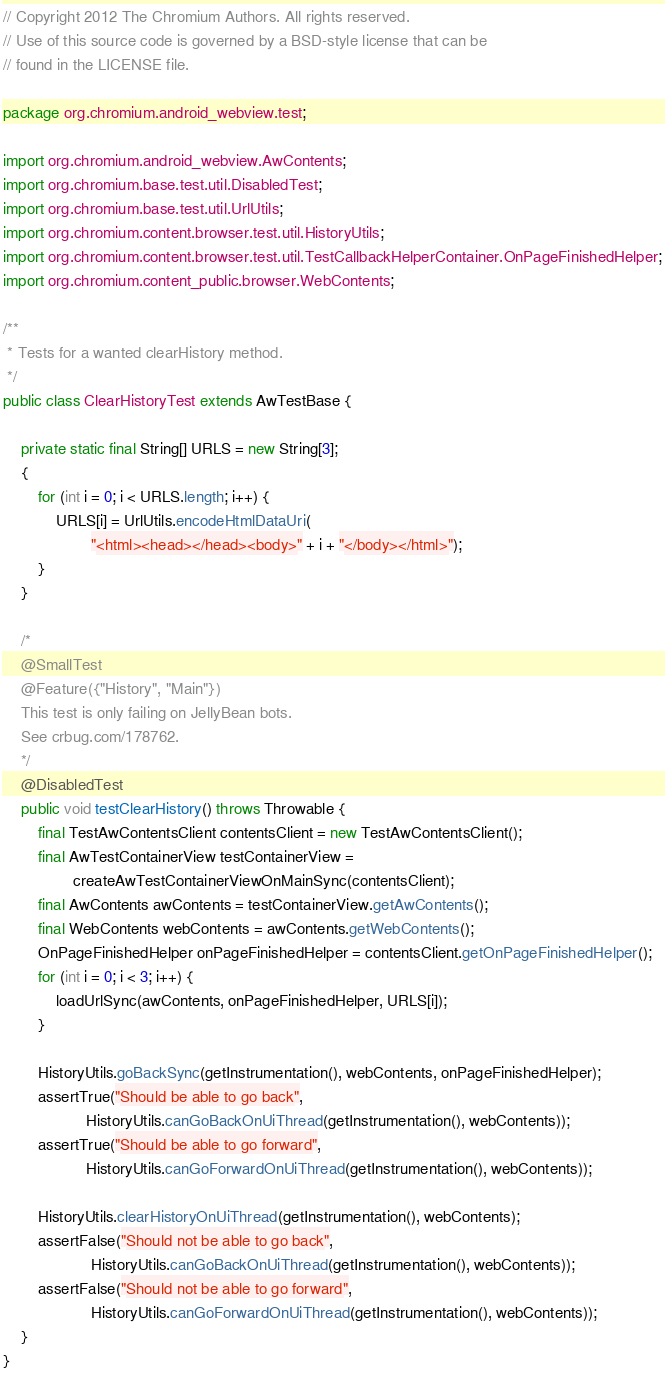Convert code to text. <code><loc_0><loc_0><loc_500><loc_500><_Java_>// Copyright 2012 The Chromium Authors. All rights reserved.
// Use of this source code is governed by a BSD-style license that can be
// found in the LICENSE file.

package org.chromium.android_webview.test;

import org.chromium.android_webview.AwContents;
import org.chromium.base.test.util.DisabledTest;
import org.chromium.base.test.util.UrlUtils;
import org.chromium.content.browser.test.util.HistoryUtils;
import org.chromium.content.browser.test.util.TestCallbackHelperContainer.OnPageFinishedHelper;
import org.chromium.content_public.browser.WebContents;

/**
 * Tests for a wanted clearHistory method.
 */
public class ClearHistoryTest extends AwTestBase {

    private static final String[] URLS = new String[3];
    {
        for (int i = 0; i < URLS.length; i++) {
            URLS[i] = UrlUtils.encodeHtmlDataUri(
                    "<html><head></head><body>" + i + "</body></html>");
        }
    }

    /*
    @SmallTest
    @Feature({"History", "Main"})
    This test is only failing on JellyBean bots.
    See crbug.com/178762.
    */
    @DisabledTest
    public void testClearHistory() throws Throwable {
        final TestAwContentsClient contentsClient = new TestAwContentsClient();
        final AwTestContainerView testContainerView =
                createAwTestContainerViewOnMainSync(contentsClient);
        final AwContents awContents = testContainerView.getAwContents();
        final WebContents webContents = awContents.getWebContents();
        OnPageFinishedHelper onPageFinishedHelper = contentsClient.getOnPageFinishedHelper();
        for (int i = 0; i < 3; i++) {
            loadUrlSync(awContents, onPageFinishedHelper, URLS[i]);
        }

        HistoryUtils.goBackSync(getInstrumentation(), webContents, onPageFinishedHelper);
        assertTrue("Should be able to go back",
                   HistoryUtils.canGoBackOnUiThread(getInstrumentation(), webContents));
        assertTrue("Should be able to go forward",
                   HistoryUtils.canGoForwardOnUiThread(getInstrumentation(), webContents));

        HistoryUtils.clearHistoryOnUiThread(getInstrumentation(), webContents);
        assertFalse("Should not be able to go back",
                    HistoryUtils.canGoBackOnUiThread(getInstrumentation(), webContents));
        assertFalse("Should not be able to go forward",
                    HistoryUtils.canGoForwardOnUiThread(getInstrumentation(), webContents));
    }
}
</code> 